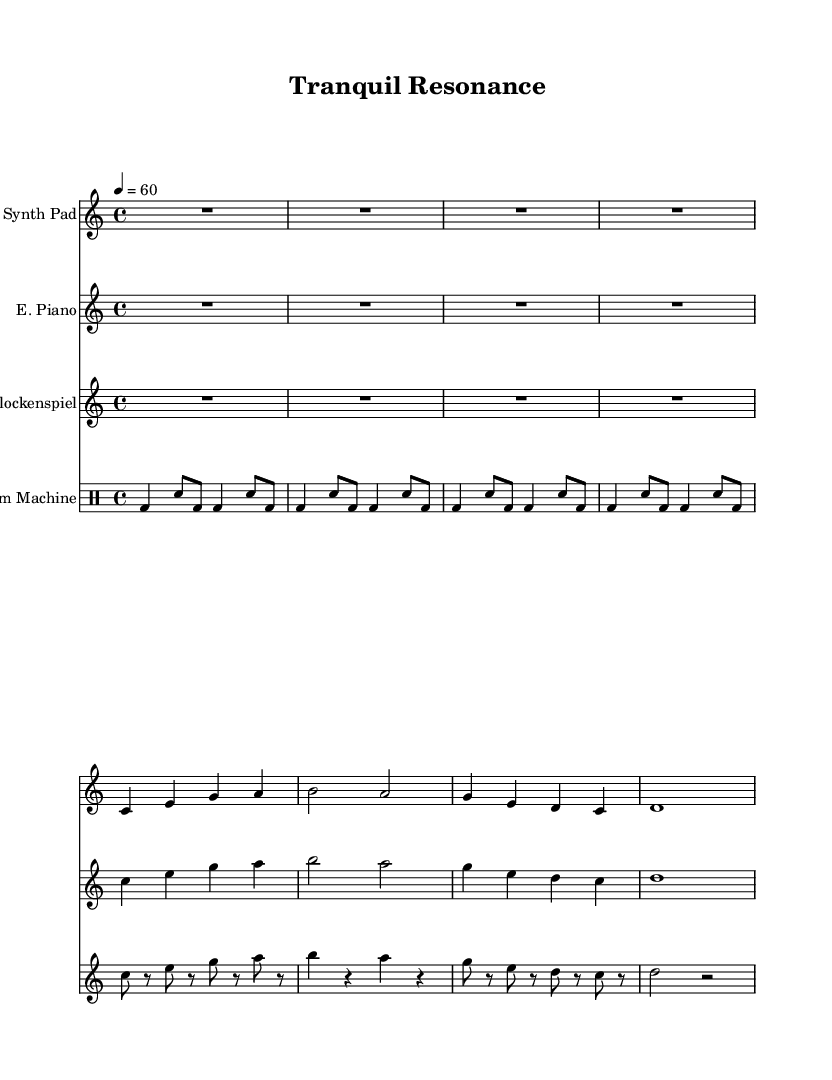What is the key signature of this music? The key signature, indicated at the beginning of the sheet music, shows no sharps or flats, meaning it is in C major.
Answer: C major What is the time signature of this music? The time signature, seen at the beginning of the sheet music, indicates that there are four beats in each measure, which is notated as 4/4.
Answer: 4/4 What is the tempo marking? The tempo marking is located below the title, and it indicates a speed of 60 beats per minute.
Answer: 60 How many measures are in the Synth Pad part? The Synth Pad part consists of four measures, as indicated by the notation spanning over that length before the double bar is reached.
Answer: 4 Which instrument plays the shortest note values? Upon examining the note values, the glockenspiel part features the shortest note durations with eighth notes present, as indicated by the notation.
Answer: Glockenspiel What is the rhythmic pattern used in the drum machine part? By analyzing the drum machine part, the pattern includes alternating bass drum and snare notes, specifically starting with bass drum on beats 1 and 3, and snare on the off-beats.
Answer: Alternating bass and snare How does the music reflect a mindfulness theme? The music utilizes gentle, sustained notes and calming rhythms throughout, which are characteristic of ambient electronic soundscapes intended to promote relaxation and mindfulness.
Answer: Calming soundscapes 